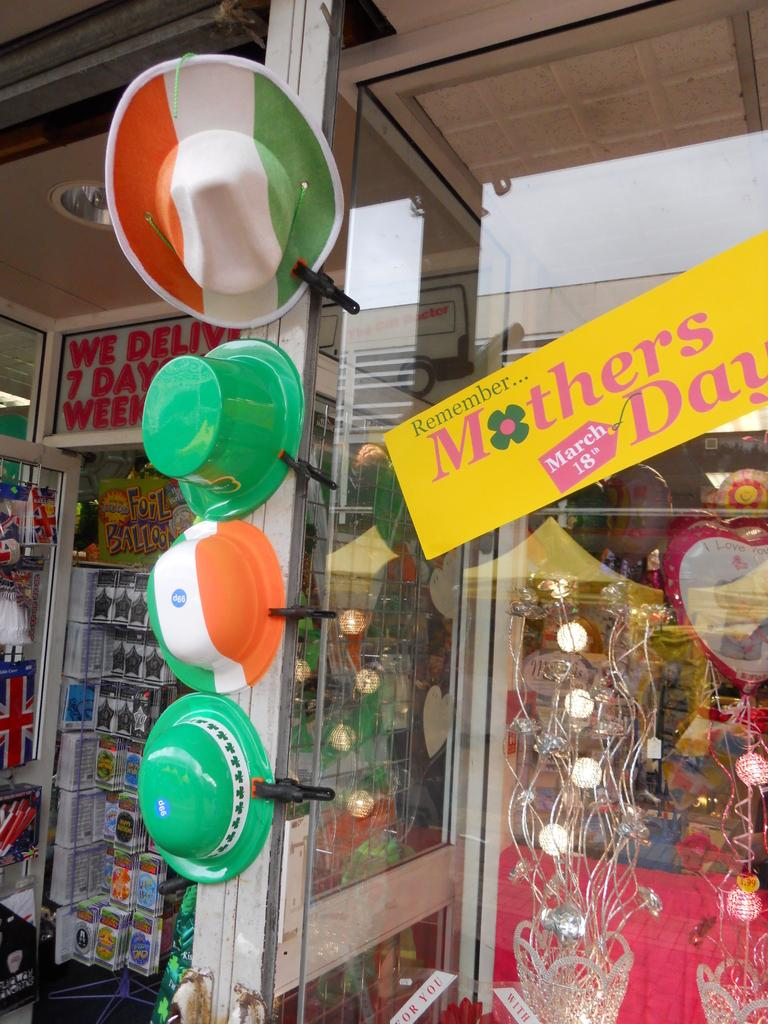What type of establishment is depicted in the image? There is a shop in the image. What can be seen on the board inside the shop? The details about the board are not mentioned in the facts, so we cannot answer this question definitively. What type of lighting is present in the shop? There is a light in the shop. What type of products are available in the shop? The shop has hats, flower vases, and items packed in boxes. Are there any decorative items in the shop? Yes, there is a balloon in the shop. What additional detail can be observed about the items in the shop? There are stickers on the glasses in the shop. What type of chain is hanging from the sky in the image? There is no chain hanging from the sky in the image, as the facts only mention the presence of a shop and its contents. 